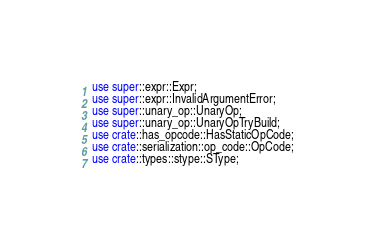Convert code to text. <code><loc_0><loc_0><loc_500><loc_500><_Rust_>use super::expr::Expr;
use super::expr::InvalidArgumentError;
use super::unary_op::UnaryOp;
use super::unary_op::UnaryOpTryBuild;
use crate::has_opcode::HasStaticOpCode;
use crate::serialization::op_code::OpCode;
use crate::types::stype::SType;
</code> 